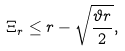<formula> <loc_0><loc_0><loc_500><loc_500>\Xi _ { r } \leq r - \sqrt { \frac { \vartheta r } { 2 } } ,</formula> 